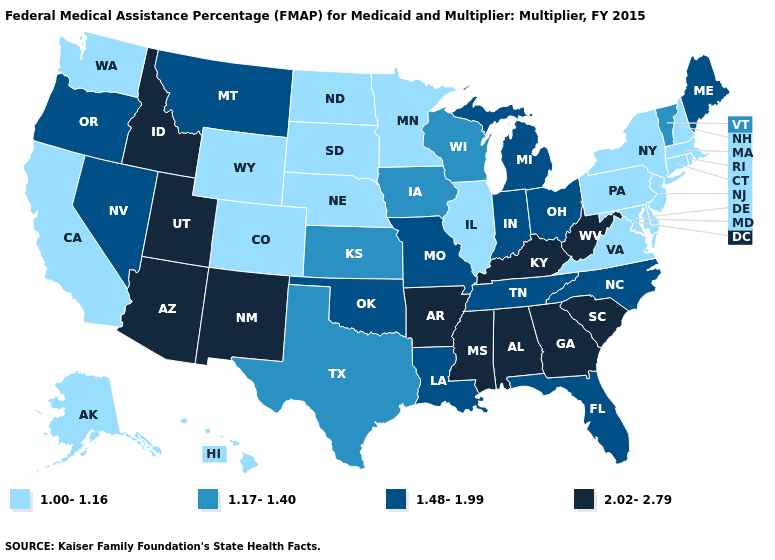Does Kentucky have a higher value than Illinois?
Concise answer only. Yes. Which states have the highest value in the USA?
Write a very short answer. Alabama, Arizona, Arkansas, Georgia, Idaho, Kentucky, Mississippi, New Mexico, South Carolina, Utah, West Virginia. What is the lowest value in the USA?
Keep it brief. 1.00-1.16. Does the map have missing data?
Answer briefly. No. Name the states that have a value in the range 2.02-2.79?
Quick response, please. Alabama, Arizona, Arkansas, Georgia, Idaho, Kentucky, Mississippi, New Mexico, South Carolina, Utah, West Virginia. Does the map have missing data?
Give a very brief answer. No. What is the value of Tennessee?
Quick response, please. 1.48-1.99. Which states have the highest value in the USA?
Write a very short answer. Alabama, Arizona, Arkansas, Georgia, Idaho, Kentucky, Mississippi, New Mexico, South Carolina, Utah, West Virginia. Does the first symbol in the legend represent the smallest category?
Quick response, please. Yes. What is the lowest value in states that border West Virginia?
Concise answer only. 1.00-1.16. Does the map have missing data?
Answer briefly. No. Does California have a lower value than Minnesota?
Give a very brief answer. No. Name the states that have a value in the range 2.02-2.79?
Quick response, please. Alabama, Arizona, Arkansas, Georgia, Idaho, Kentucky, Mississippi, New Mexico, South Carolina, Utah, West Virginia. Does New Jersey have the same value as Colorado?
Concise answer only. Yes. Does New Jersey have the highest value in the Northeast?
Keep it brief. No. 